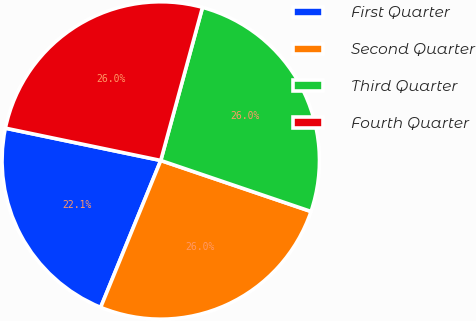<chart> <loc_0><loc_0><loc_500><loc_500><pie_chart><fcel>First Quarter<fcel>Second Quarter<fcel>Third Quarter<fcel>Fourth Quarter<nl><fcel>22.08%<fcel>25.97%<fcel>25.97%<fcel>25.97%<nl></chart> 